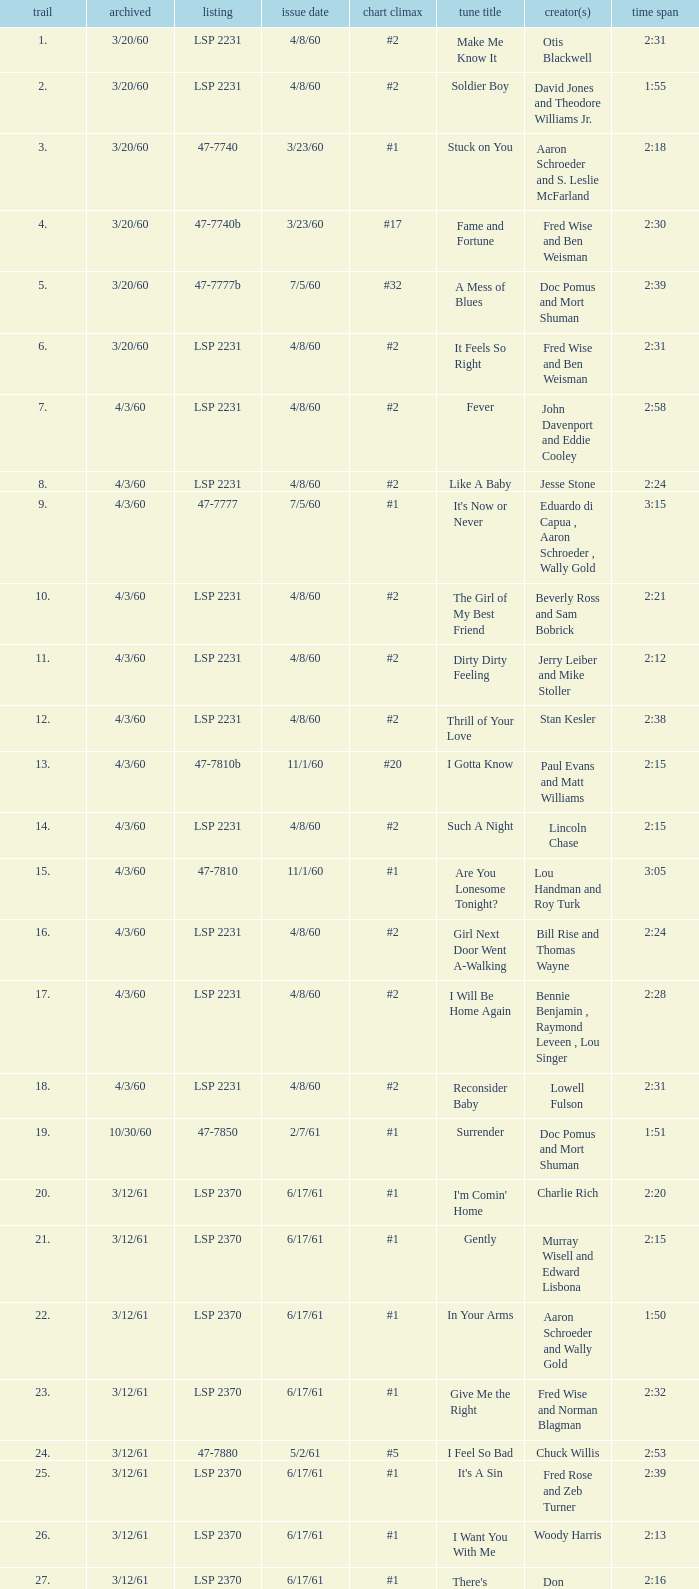What catalogue is the song It's Now or Never? 47-7777. 